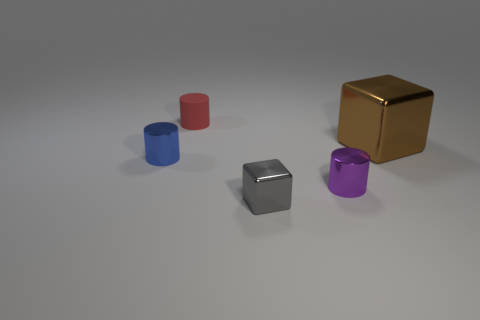Subtract all small blue shiny cylinders. How many cylinders are left? 2 Add 3 large gray metal objects. How many objects exist? 8 Subtract all purple blocks. Subtract all gray balls. How many blocks are left? 2 Subtract all blocks. How many objects are left? 3 Subtract all tiny purple metal cylinders. Subtract all large shiny blocks. How many objects are left? 3 Add 4 small gray metal things. How many small gray metal things are left? 5 Add 2 large gray shiny cylinders. How many large gray shiny cylinders exist? 2 Subtract 0 yellow cubes. How many objects are left? 5 